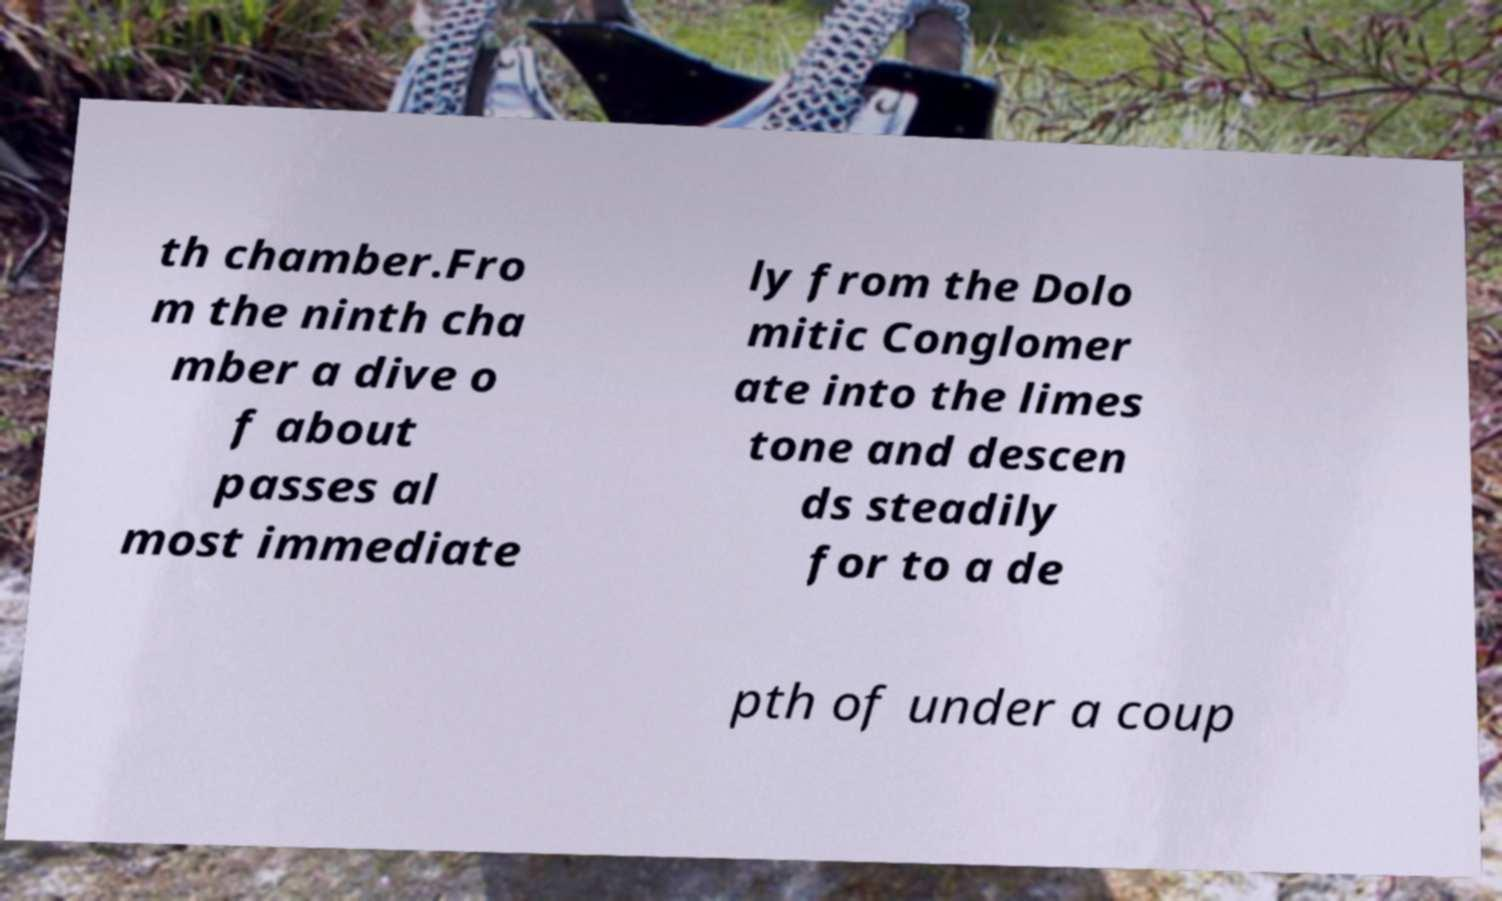Please identify and transcribe the text found in this image. th chamber.Fro m the ninth cha mber a dive o f about passes al most immediate ly from the Dolo mitic Conglomer ate into the limes tone and descen ds steadily for to a de pth of under a coup 